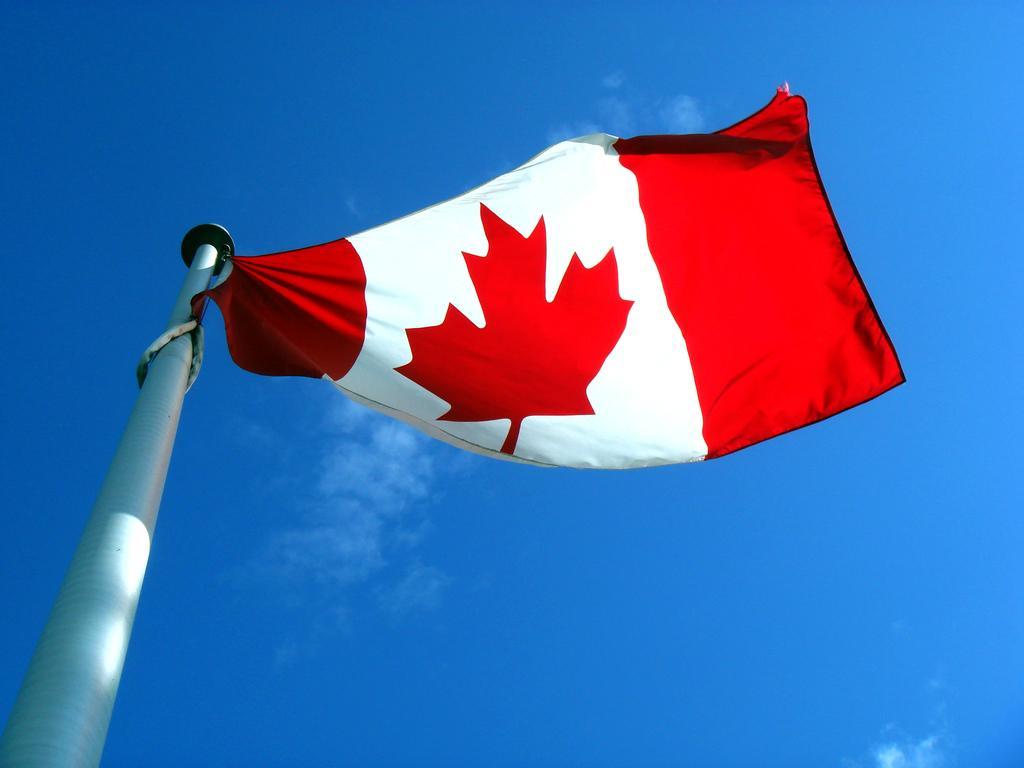In one or two sentences, can you explain what this image depicts? In this image on the left side I can see a flag. In the background, I can see the clouds in the sky. 